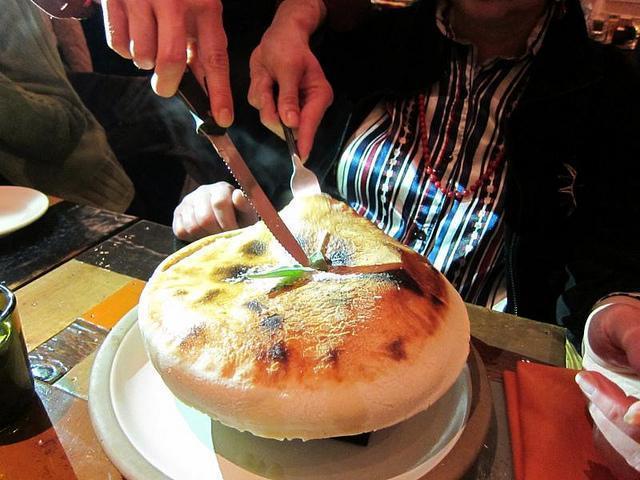How many dining tables are there?
Give a very brief answer. 2. How many people are in the photo?
Give a very brief answer. 3. 